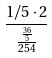Convert formula to latex. <formula><loc_0><loc_0><loc_500><loc_500>\frac { 1 / 5 \cdot 2 } { \frac { \frac { 3 6 } { 5 } } { 2 5 4 } }</formula> 